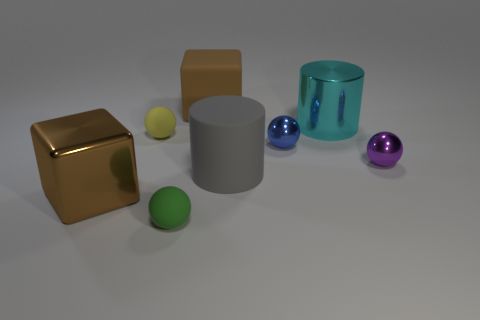Add 1 brown metallic objects. How many objects exist? 9 Subtract all cylinders. How many objects are left? 6 Subtract all small blue metal balls. Subtract all small red matte spheres. How many objects are left? 7 Add 8 small metal spheres. How many small metal spheres are left? 10 Add 6 small things. How many small things exist? 10 Subtract 1 yellow spheres. How many objects are left? 7 